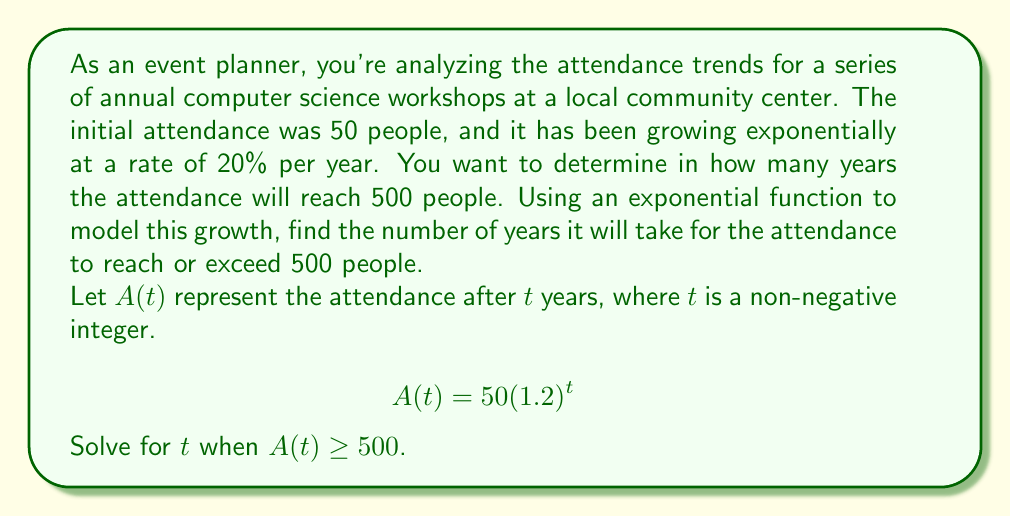Give your solution to this math problem. Let's approach this step-by-step:

1) We start with the exponential function:
   $$A(t) = 50(1.2)^t$$

2) We want to find $t$ when $A(t) \geq 500$, so we set up the inequality:
   $$50(1.2)^t \geq 500$$

3) Divide both sides by 50:
   $$(1.2)^t \geq 10$$

4) Now, we can take the logarithm of both sides. Since we're dealing with an inequality, we need to be careful. However, since the base of the exponential (1.2) is greater than 1, the inequality direction remains the same:
   $$\log(1.2)^t \geq \log(10)$$

5) Using the logarithm property $\log(a^b) = b\log(a)$, we get:
   $$t\log(1.2) \geq \log(10)$$

6) Divide both sides by $\log(1.2)$:
   $$t \geq \frac{\log(10)}{\log(1.2)}$$

7) Using a calculator (or computer):
   $$t \geq 12.3785...$$

8) Since $t$ represents years and must be a whole number, we need to round up to the next integer.

Therefore, the attendance will reach or exceed 500 people after 13 years.
Answer: 13 years 